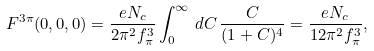<formula> <loc_0><loc_0><loc_500><loc_500>F ^ { 3 \pi } ( 0 , 0 , 0 ) = \frac { e N _ { c } } { 2 \pi ^ { 2 } f _ { \pi } ^ { 3 } } \int _ { 0 } ^ { \infty } \, d C \, \frac { C } { ( 1 + C ) ^ { 4 } } = \frac { e N _ { c } } { 1 2 \pi ^ { 2 } f _ { \pi } ^ { 3 } } ,</formula> 